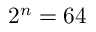<formula> <loc_0><loc_0><loc_500><loc_500>2 ^ { n } = 6 4</formula> 